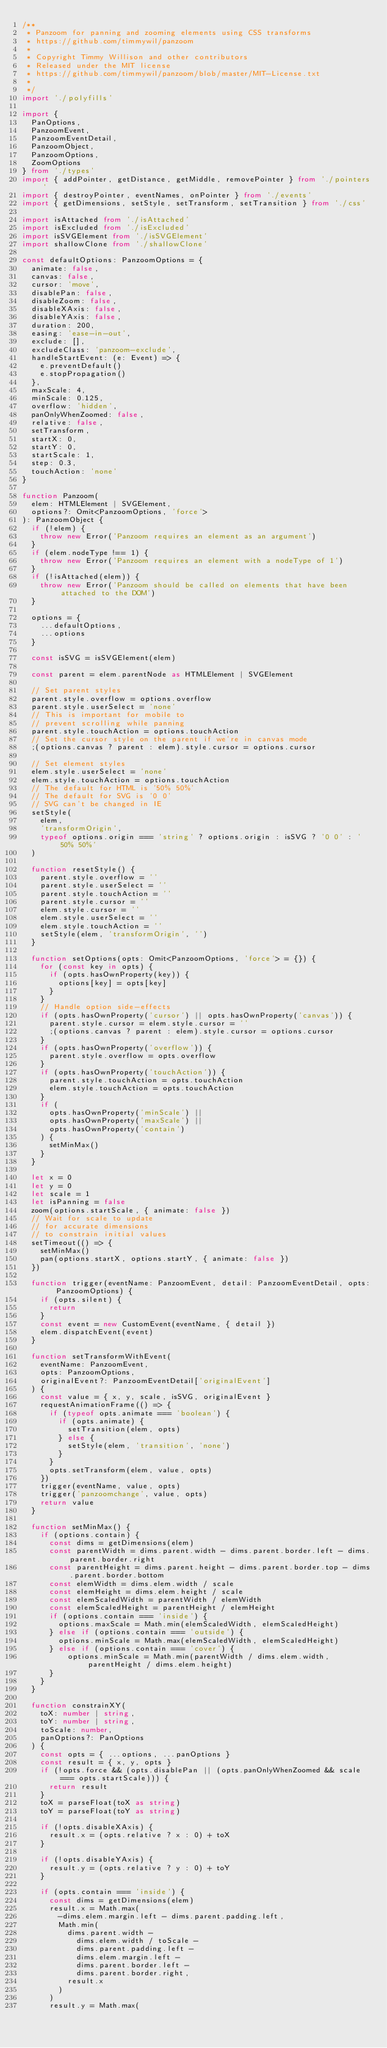Convert code to text. <code><loc_0><loc_0><loc_500><loc_500><_TypeScript_>/**
 * Panzoom for panning and zooming elements using CSS transforms
 * https://github.com/timmywil/panzoom
 *
 * Copyright Timmy Willison and other contributors
 * Released under the MIT license
 * https://github.com/timmywil/panzoom/blob/master/MIT-License.txt
 *
 */
import './polyfills'

import {
  PanOptions,
  PanzoomEvent,
  PanzoomEventDetail,
  PanzoomObject,
  PanzoomOptions,
  ZoomOptions
} from './types'
import { addPointer, getDistance, getMiddle, removePointer } from './pointers'
import { destroyPointer, eventNames, onPointer } from './events'
import { getDimensions, setStyle, setTransform, setTransition } from './css'

import isAttached from './isAttached'
import isExcluded from './isExcluded'
import isSVGElement from './isSVGElement'
import shallowClone from './shallowClone'

const defaultOptions: PanzoomOptions = {
  animate: false,
  canvas: false,
  cursor: 'move',
  disablePan: false,
  disableZoom: false,
  disableXAxis: false,
  disableYAxis: false,
  duration: 200,
  easing: 'ease-in-out',
  exclude: [],
  excludeClass: 'panzoom-exclude',
  handleStartEvent: (e: Event) => {
    e.preventDefault()
    e.stopPropagation()
  },
  maxScale: 4,
  minScale: 0.125,
  overflow: 'hidden',
  panOnlyWhenZoomed: false,
  relative: false,
  setTransform,
  startX: 0,
  startY: 0,
  startScale: 1,
  step: 0.3,
  touchAction: 'none'
}

function Panzoom(
  elem: HTMLElement | SVGElement,
  options?: Omit<PanzoomOptions, 'force'>
): PanzoomObject {
  if (!elem) {
    throw new Error('Panzoom requires an element as an argument')
  }
  if (elem.nodeType !== 1) {
    throw new Error('Panzoom requires an element with a nodeType of 1')
  }
  if (!isAttached(elem)) {
    throw new Error('Panzoom should be called on elements that have been attached to the DOM')
  }

  options = {
    ...defaultOptions,
    ...options
  }

  const isSVG = isSVGElement(elem)

  const parent = elem.parentNode as HTMLElement | SVGElement

  // Set parent styles
  parent.style.overflow = options.overflow
  parent.style.userSelect = 'none'
  // This is important for mobile to
  // prevent scrolling while panning
  parent.style.touchAction = options.touchAction
  // Set the cursor style on the parent if we're in canvas mode
  ;(options.canvas ? parent : elem).style.cursor = options.cursor

  // Set element styles
  elem.style.userSelect = 'none'
  elem.style.touchAction = options.touchAction
  // The default for HTML is '50% 50%'
  // The default for SVG is '0 0'
  // SVG can't be changed in IE
  setStyle(
    elem,
    'transformOrigin',
    typeof options.origin === 'string' ? options.origin : isSVG ? '0 0' : '50% 50%'
  )

  function resetStyle() {
    parent.style.overflow = ''
    parent.style.userSelect = ''
    parent.style.touchAction = ''
    parent.style.cursor = ''
    elem.style.cursor = ''
    elem.style.userSelect = ''
    elem.style.touchAction = ''
    setStyle(elem, 'transformOrigin', '')
  }

  function setOptions(opts: Omit<PanzoomOptions, 'force'> = {}) {
    for (const key in opts) {
      if (opts.hasOwnProperty(key)) {
        options[key] = opts[key]
      }
    }
    // Handle option side-effects
    if (opts.hasOwnProperty('cursor') || opts.hasOwnProperty('canvas')) {
      parent.style.cursor = elem.style.cursor = ''
      ;(options.canvas ? parent : elem).style.cursor = options.cursor
    }
    if (opts.hasOwnProperty('overflow')) {
      parent.style.overflow = opts.overflow
    }
    if (opts.hasOwnProperty('touchAction')) {
      parent.style.touchAction = opts.touchAction
      elem.style.touchAction = opts.touchAction
    }
    if (
      opts.hasOwnProperty('minScale') ||
      opts.hasOwnProperty('maxScale') ||
      opts.hasOwnProperty('contain')
    ) {
      setMinMax()
    }
  }

  let x = 0
  let y = 0
  let scale = 1
  let isPanning = false
  zoom(options.startScale, { animate: false })
  // Wait for scale to update
  // for accurate dimensions
  // to constrain initial values
  setTimeout(() => {
    setMinMax()
    pan(options.startX, options.startY, { animate: false })
  })

  function trigger(eventName: PanzoomEvent, detail: PanzoomEventDetail, opts: PanzoomOptions) {
    if (opts.silent) {
      return
    }
    const event = new CustomEvent(eventName, { detail })
    elem.dispatchEvent(event)
  }

  function setTransformWithEvent(
    eventName: PanzoomEvent,
    opts: PanzoomOptions,
    originalEvent?: PanzoomEventDetail['originalEvent']
  ) {
    const value = { x, y, scale, isSVG, originalEvent }
    requestAnimationFrame(() => {
      if (typeof opts.animate === 'boolean') {
        if (opts.animate) {
          setTransition(elem, opts)
        } else {
          setStyle(elem, 'transition', 'none')
        }
      }
      opts.setTransform(elem, value, opts)
    })
    trigger(eventName, value, opts)
    trigger('panzoomchange', value, opts)
    return value
  }

  function setMinMax() {
    if (options.contain) {
      const dims = getDimensions(elem)
      const parentWidth = dims.parent.width - dims.parent.border.left - dims.parent.border.right
      const parentHeight = dims.parent.height - dims.parent.border.top - dims.parent.border.bottom
      const elemWidth = dims.elem.width / scale
      const elemHeight = dims.elem.height / scale
      const elemScaledWidth = parentWidth / elemWidth
      const elemScaledHeight = parentHeight / elemHeight
      if (options.contain === 'inside') {
        options.maxScale = Math.min(elemScaledWidth, elemScaledHeight)
      } else if (options.contain === 'outside') {
        options.minScale = Math.max(elemScaledWidth, elemScaledHeight)
      } else if (options.contain === 'cover') {
          options.minScale = Math.min(parentWidth / dims.elem.width, parentHeight / dims.elem.height)
      }
    }
  }

  function constrainXY(
    toX: number | string,
    toY: number | string,
    toScale: number,
    panOptions?: PanOptions
  ) {
    const opts = { ...options, ...panOptions }
    const result = { x, y, opts }
    if (!opts.force && (opts.disablePan || (opts.panOnlyWhenZoomed && scale === opts.startScale))) {
      return result
    }
    toX = parseFloat(toX as string)
    toY = parseFloat(toY as string)

    if (!opts.disableXAxis) {
      result.x = (opts.relative ? x : 0) + toX
    }

    if (!opts.disableYAxis) {
      result.y = (opts.relative ? y : 0) + toY
    }

    if (opts.contain === 'inside') {
      const dims = getDimensions(elem)
      result.x = Math.max(
        -dims.elem.margin.left - dims.parent.padding.left,
        Math.min(
          dims.parent.width -
            dims.elem.width / toScale -
            dims.parent.padding.left -
            dims.elem.margin.left -
            dims.parent.border.left -
            dims.parent.border.right,
          result.x
        )
      )
      result.y = Math.max(</code> 